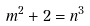<formula> <loc_0><loc_0><loc_500><loc_500>m ^ { 2 } + 2 = n ^ { 3 }</formula> 